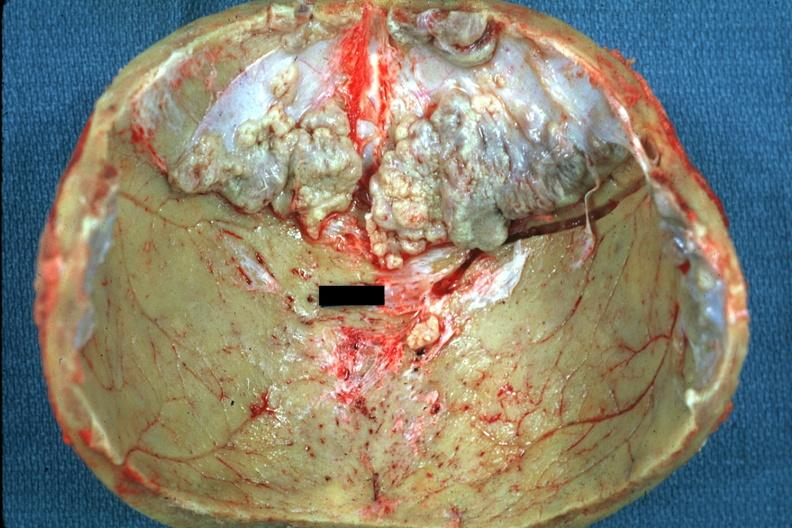does this image show several rather large lesions?
Answer the question using a single word or phrase. Yes 